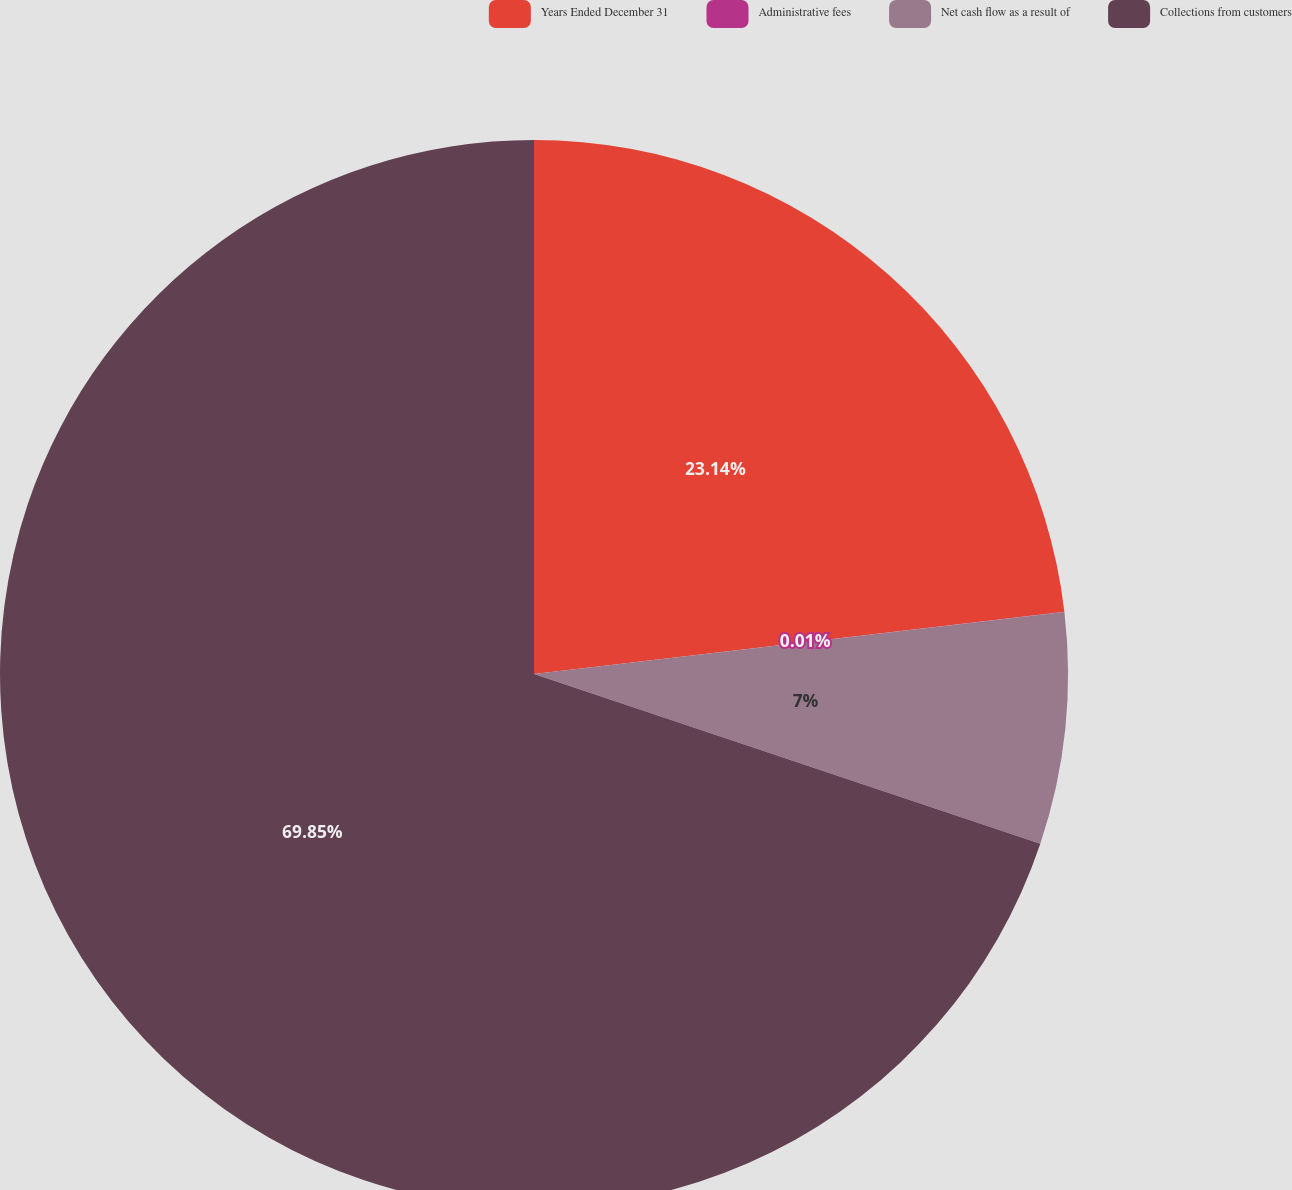<chart> <loc_0><loc_0><loc_500><loc_500><pie_chart><fcel>Years Ended December 31<fcel>Administrative fees<fcel>Net cash flow as a result of<fcel>Collections from customers<nl><fcel>23.14%<fcel>0.01%<fcel>7.0%<fcel>69.85%<nl></chart> 